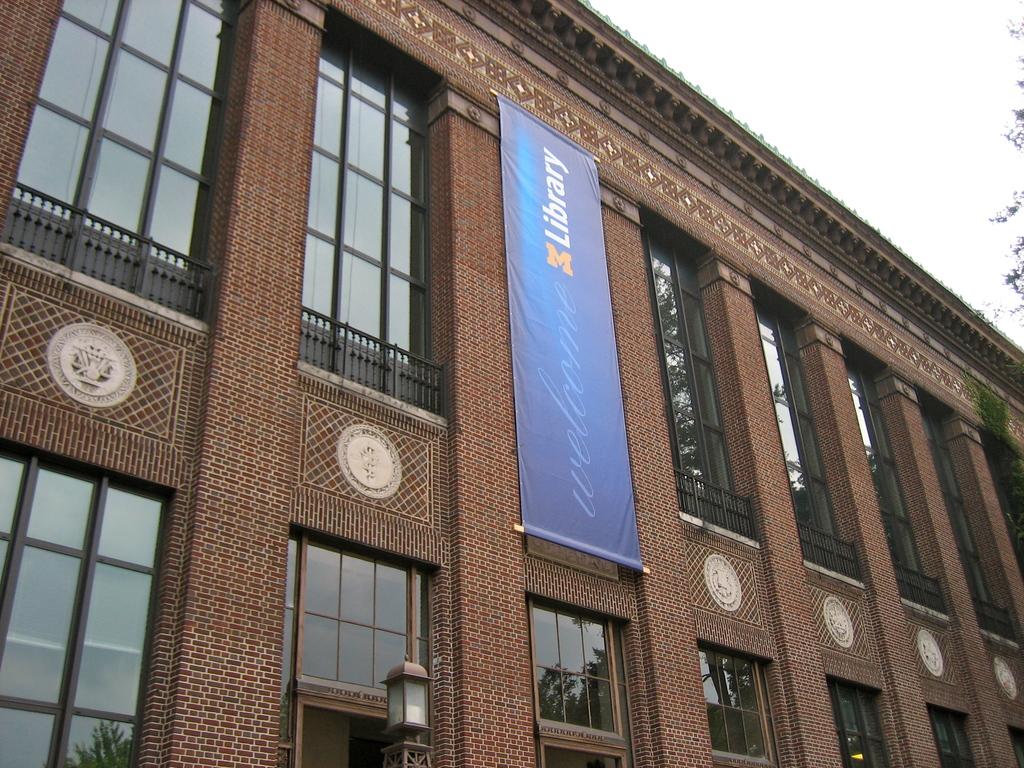What is the banner welcoming us to?
Your answer should be very brief. Library. What is the banner implying?
Offer a very short reply. Library. 